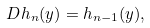Convert formula to latex. <formula><loc_0><loc_0><loc_500><loc_500>\ D h _ { n } ( { y } ) = h _ { n - 1 } ( { y } ) ,</formula> 